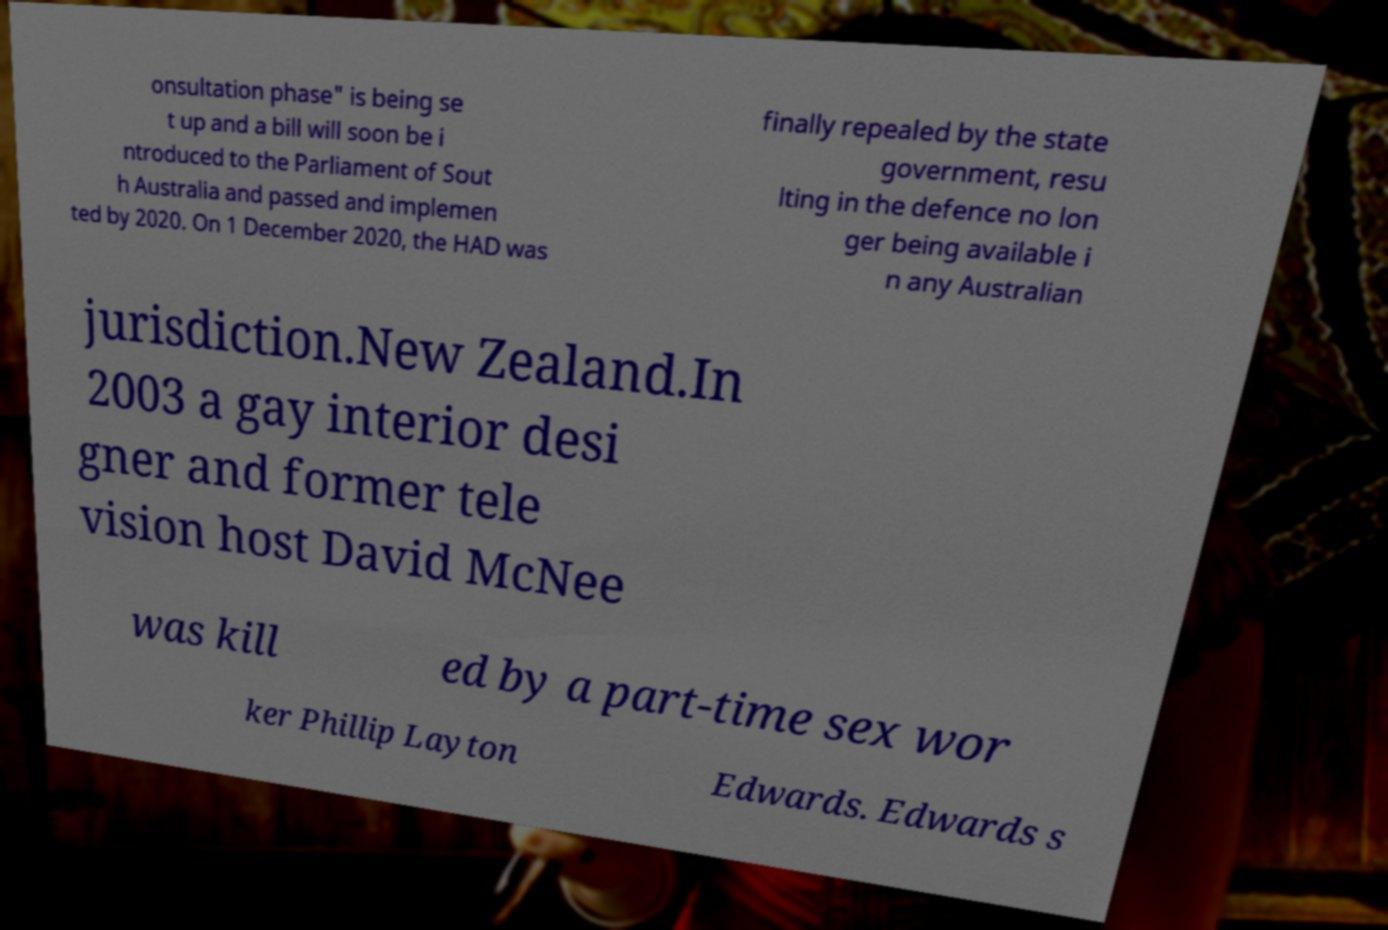Please read and relay the text visible in this image. What does it say? onsultation phase" is being se t up and a bill will soon be i ntroduced to the Parliament of Sout h Australia and passed and implemen ted by 2020. On 1 December 2020, the HAD was finally repealed by the state government, resu lting in the defence no lon ger being available i n any Australian jurisdiction.New Zealand.In 2003 a gay interior desi gner and former tele vision host David McNee was kill ed by a part-time sex wor ker Phillip Layton Edwards. Edwards s 